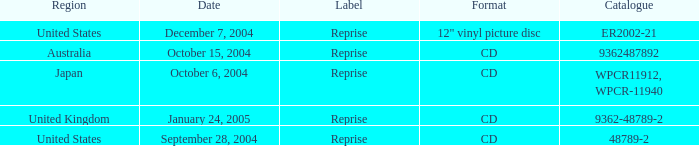Identify the label assigned to january 24, 2005. Reprise. 